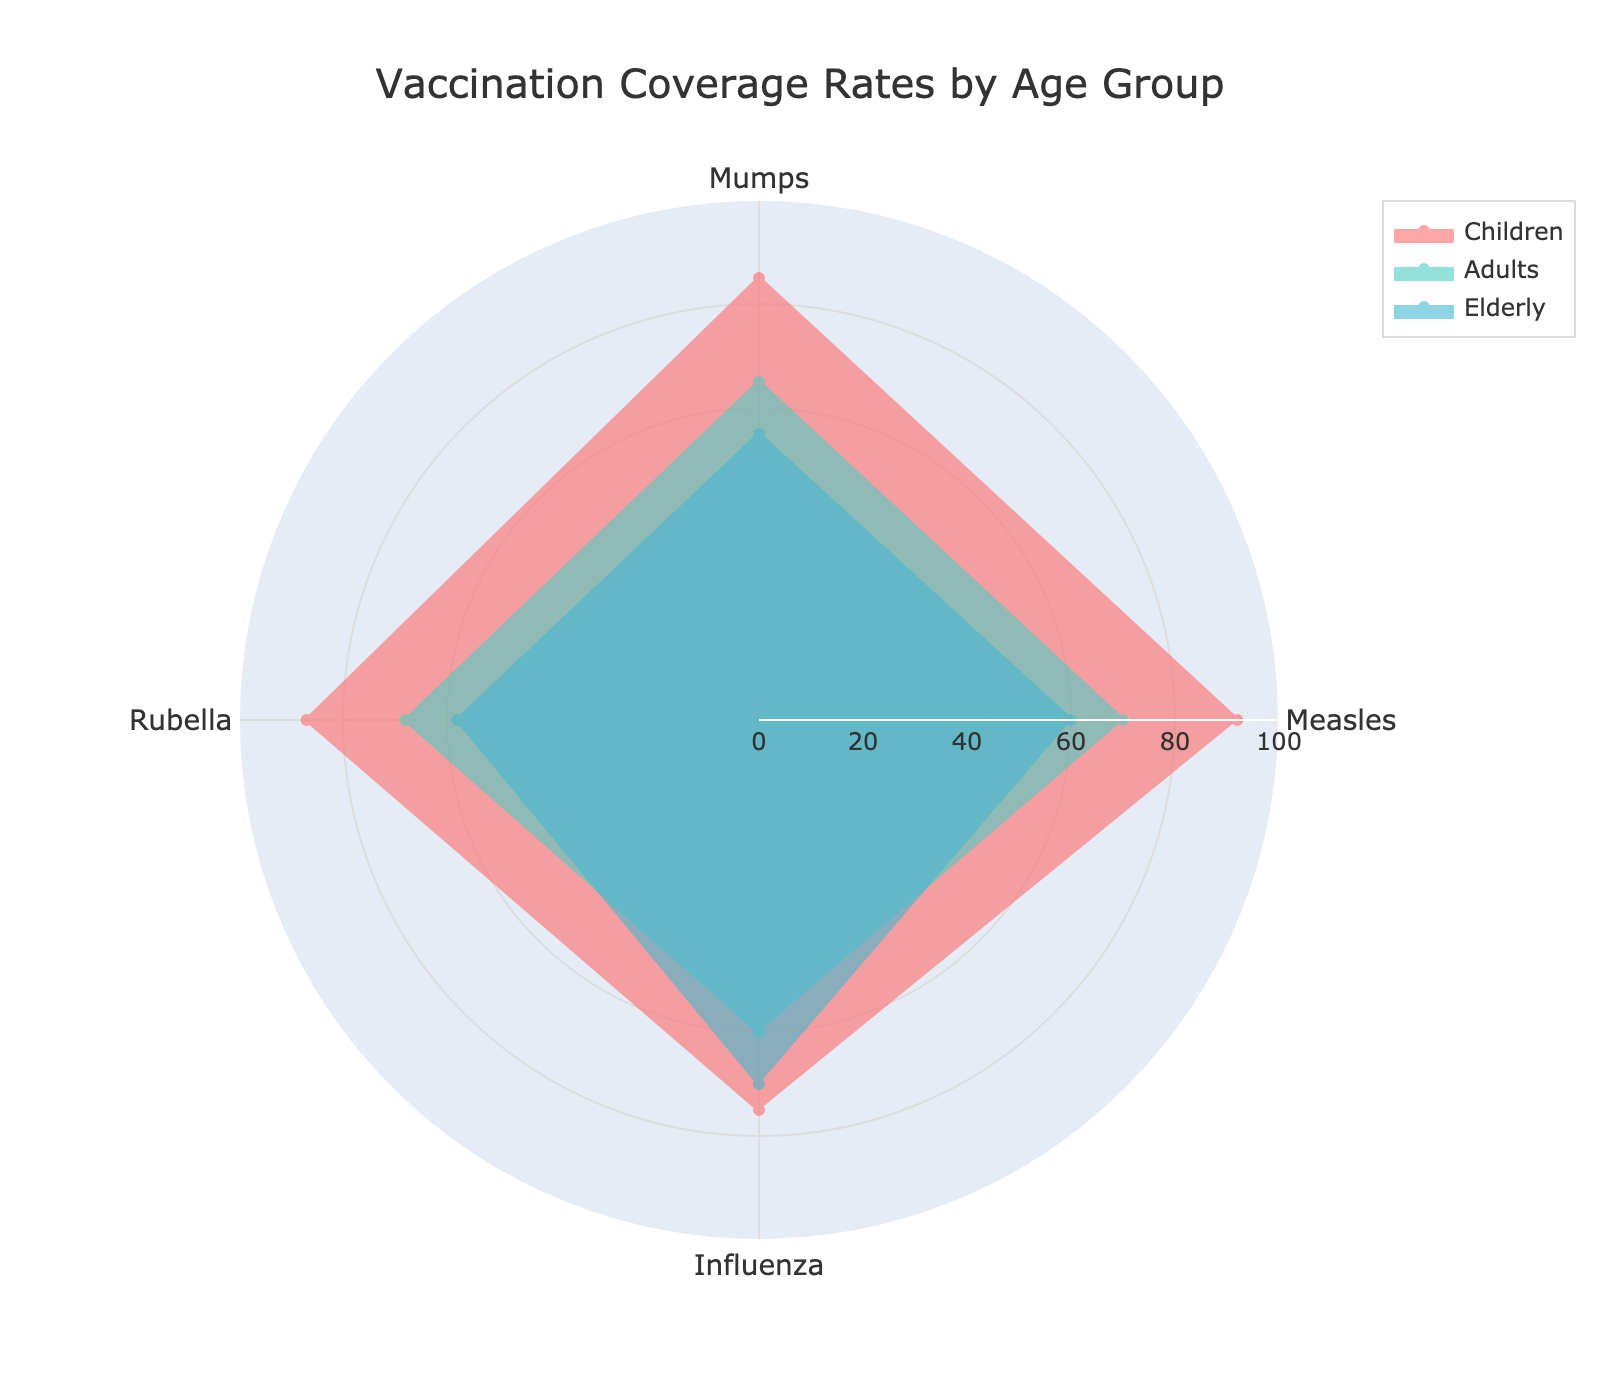What are the vaccination coverage rates for Measles in each age group? The radar chart displays different vaccination coverage rates for Measles under the categories labeled "Children," "Adults," and "Elderly." You can find the respective rates for Measles around the chart for each age group.
Answer: Children: 92, Adults: 70, Elderly: 60 Which age group has the lowest Influenza vaccination coverage rate? The radar chart shows the coverage rates for each age group. By observing the segment labeled "Influenza," you can compare the rates of "Children," "Adults," and "Elderly." The group with the smallest radius length in that segment has the lowest coverage.
Answer: Adults How does the Mumps vaccination coverage for the Children group compare to the Elderly group? To compare the coverage rates for Mumps, locate the segment labeled "Mumps" and compare the length of the radial lines for "Children" and "Elderly." The Children group's line extends farther than the Elderly group's.
Answer: Higher What is the total vaccination coverage for Rubella across all age groups? Sum the Rubella coverage rates from the radar chart where the groups are labeled "Children," "Adults," and "Elderly." The values are indicated by the length of the radial lines in the Rubella segment.
Answer: 87 + 68 + 58 = 213 Which age group has the most balanced vaccination coverage across all diseases? Analyzing balance involves looking for the age group where the four radial lines (Measles, Mumps, Rubella, Influenza) are most similar in length in the radar chart. Visual inspection helps identify that the lines for "Children" are more evenly balanced than those for "Adults" and "Elderly."
Answer: Children What is the average vaccination coverage rate for the Adults group? Identify the four coverage rates for Adults (Measles, Mumps, Rubella, Influenza) from the radar chart. Sum these values and divide by four.
Answer: (70 + 65 + 68 + 60) / 4 = 65.75 Compare the difference in Rubella coverage rates between Children and Adults. The radar chart shows the Rubella rates for both groups. Subtract the Adults' rate from the Children's rate to find the difference.
Answer: 87 - 68 = 19 Does any age group exceed 90% coverage for any vaccine? Inspect the radar chart to see if any radial line extends beyond the 90% mark. Check for each disease category.
Answer: Children (Measles) 